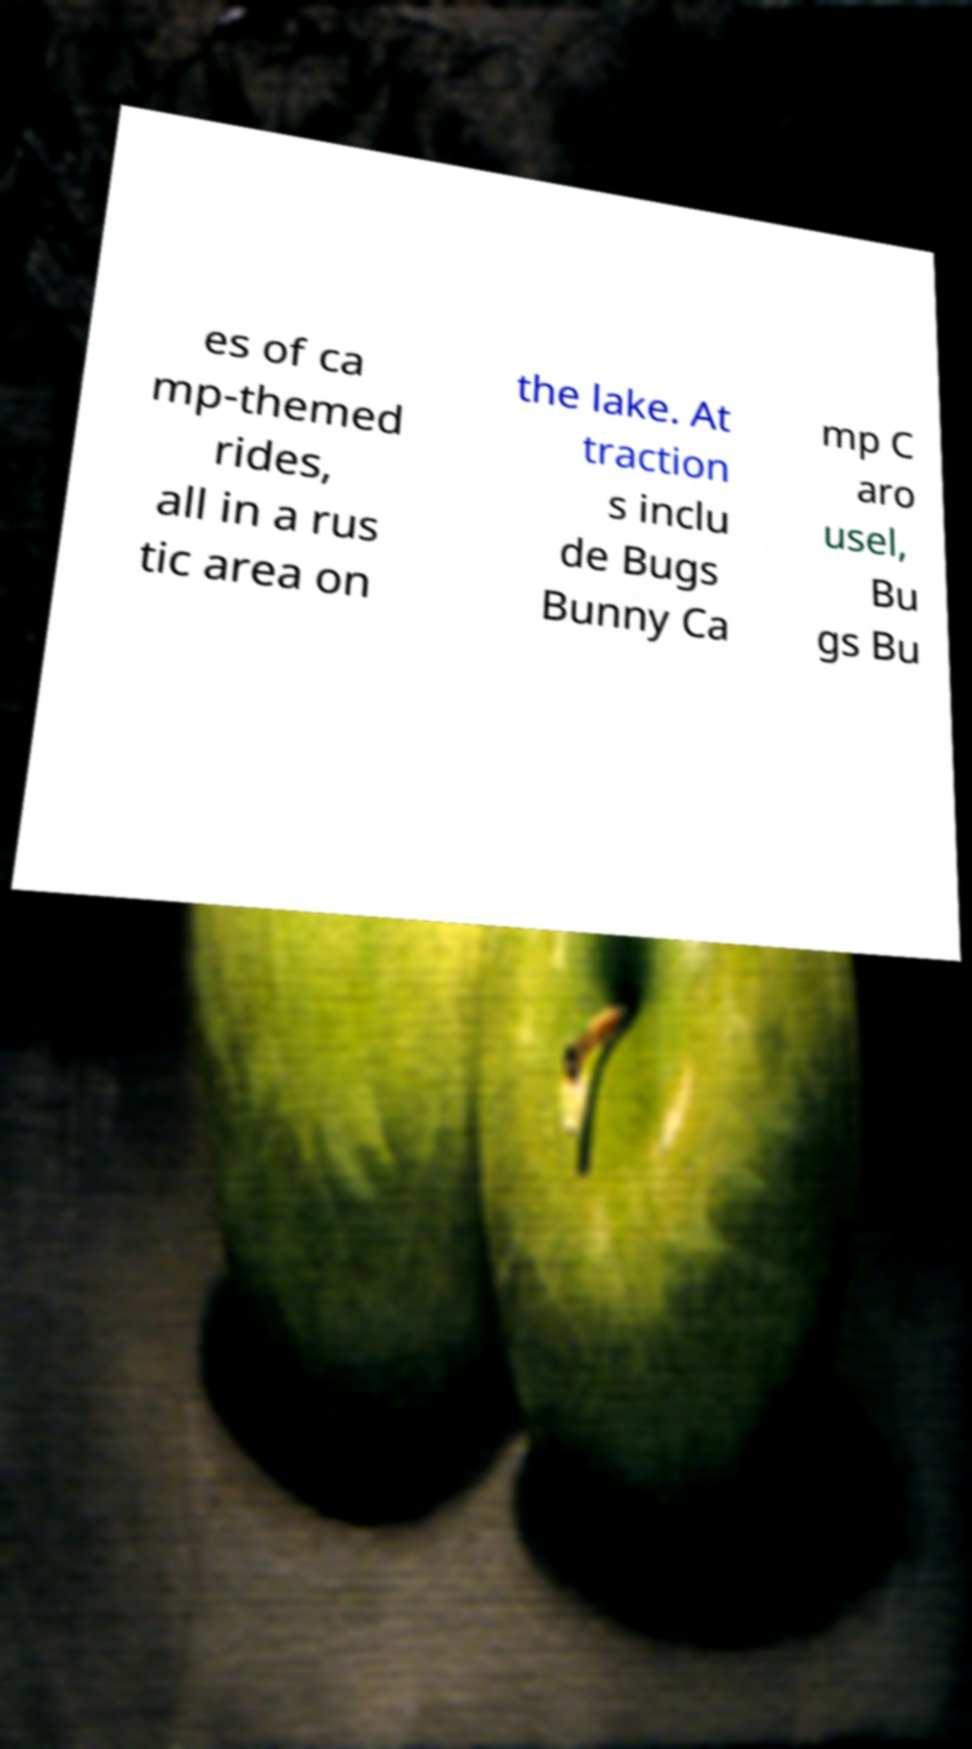I need the written content from this picture converted into text. Can you do that? es of ca mp-themed rides, all in a rus tic area on the lake. At traction s inclu de Bugs Bunny Ca mp C aro usel, Bu gs Bu 